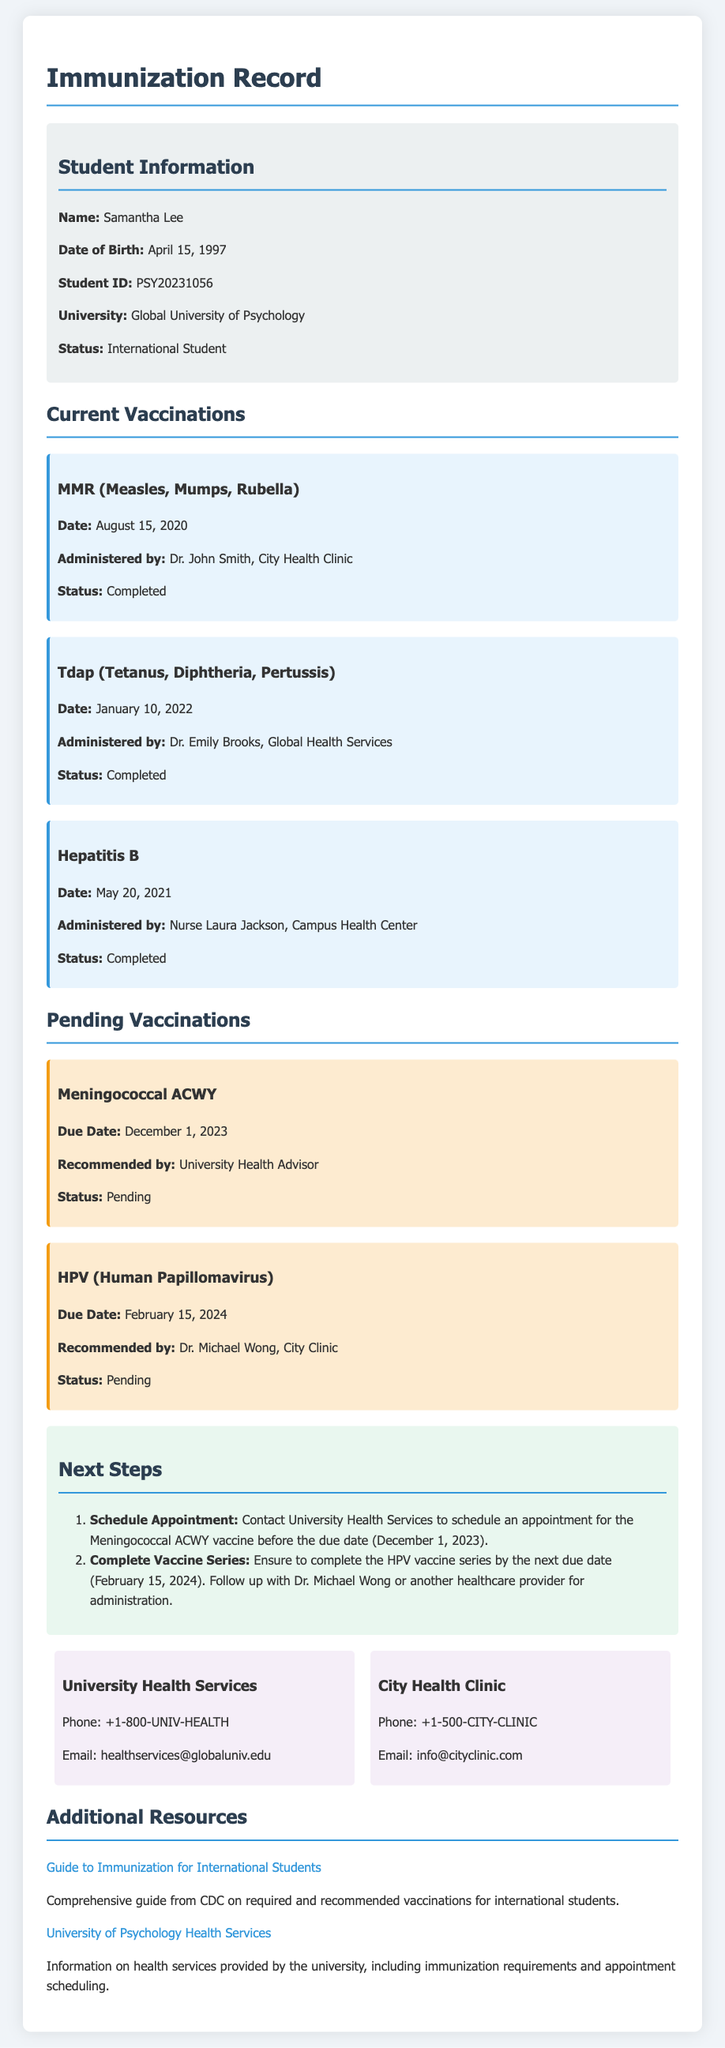What is the name of the student? The student's name is displayed in the student information section of the document.
Answer: Samantha Lee What is the due date for the Meningococcal ACWY vaccine? The due date for the Meningococcal ACWY vaccine is specified in the pending vaccinations section.
Answer: December 1, 2023 Who administered the Tdap vaccine? The name of the person who administered the Tdap vaccine is listed under the current vaccinations section.
Answer: Dr. Emily Brooks Which health service is recommended for scheduling the next vaccination? The document specifies which health service to contact for scheduling in the next steps section.
Answer: University Health Services How many current vaccinations are marked as completed? The completed vaccinations are listed in the current vaccinations section of the document.
Answer: 3 What is the recommended action for the HPV vaccine? The next steps section outlines what to do regarding the HPV vaccine.
Answer: Complete Vaccine Series What is the student ID of Samantha Lee? The student ID is provided in the student information section of the document.
Answer: PSY20231056 Which two vaccines are pending? The pending vaccinations are listed in a specific section of the document.
Answer: Meningococcal ACWY, HPV What type of document is this? The title at the top of the document indicates the nature of the content.
Answer: Immunization Record 